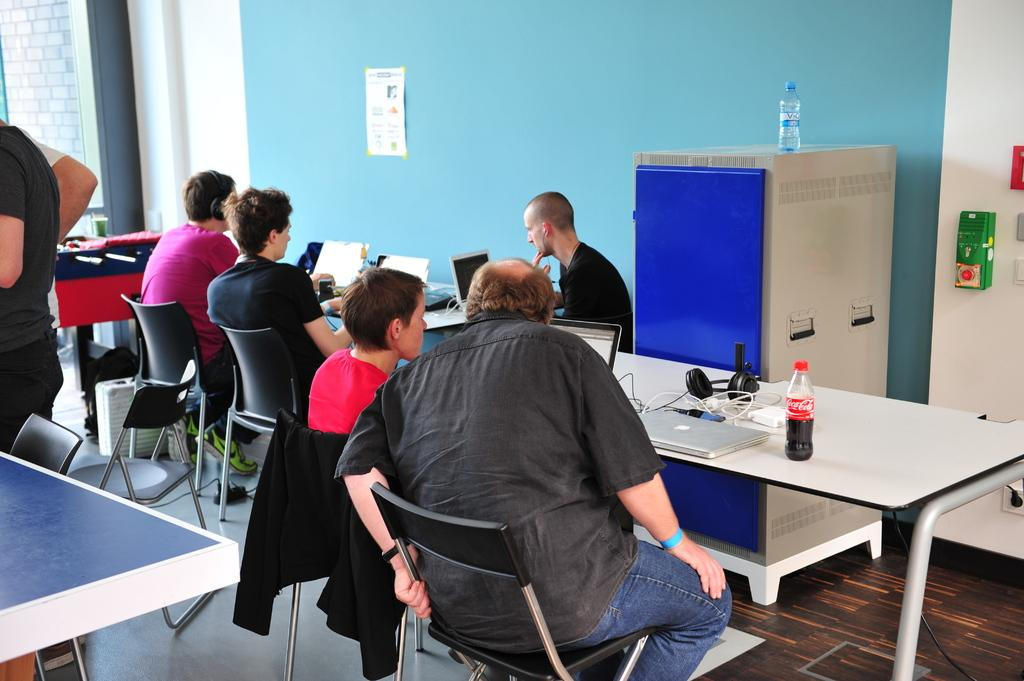How many people are in the image? There are people in the image, but the exact number is not specified. What are the people doing in the image? The people are sitting at different tables and working on their laptops. Can you describe the setting in which the people are working? The people are sitting at tables, which suggests they might be in a cafe or a similar environment. What type of books are the people reading in the image? There is no mention of books in the image; the people are working on their laptops. 